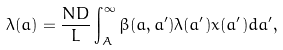Convert formula to latex. <formula><loc_0><loc_0><loc_500><loc_500>\lambda ( a ) = \frac { N D } { L } \int _ { A } ^ { \infty } \beta ( a , a ^ { \prime } ) \lambda ( a ^ { \prime } ) x ( a ^ { \prime } ) d a ^ { \prime } ,</formula> 